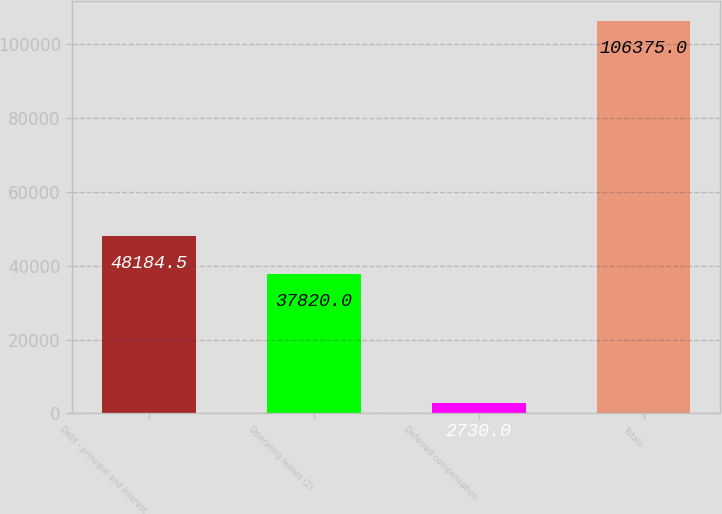Convert chart. <chart><loc_0><loc_0><loc_500><loc_500><bar_chart><fcel>Debt - principal and interest<fcel>Operating leases (2)<fcel>Deferred compensation<fcel>Totals<nl><fcel>48184.5<fcel>37820<fcel>2730<fcel>106375<nl></chart> 